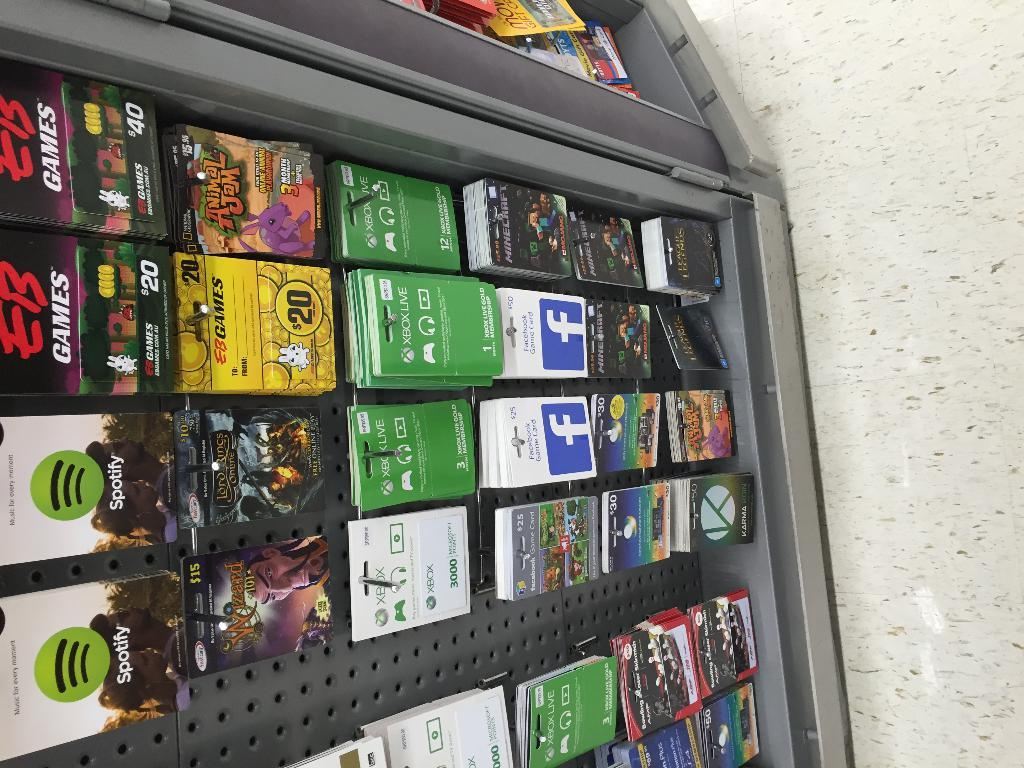<image>
Write a terse but informative summary of the picture. A rack of gift cards for various companies such as Spotify and Facebook. 